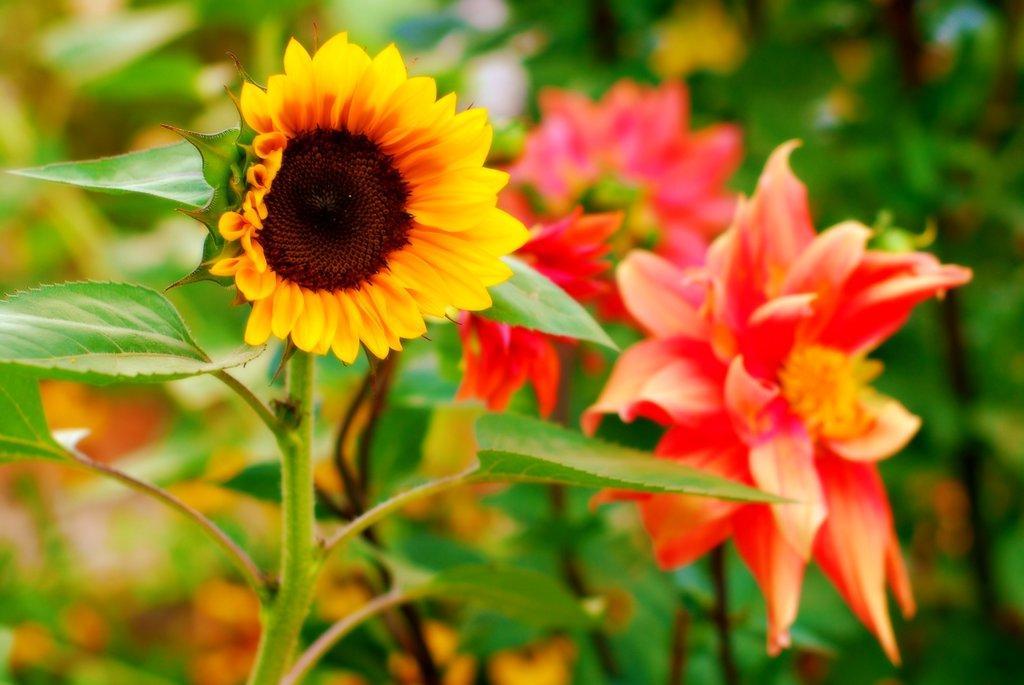Please provide a concise description of this image. This is the picture of a plant to which there are some flowers which are in yellow and orange color. 